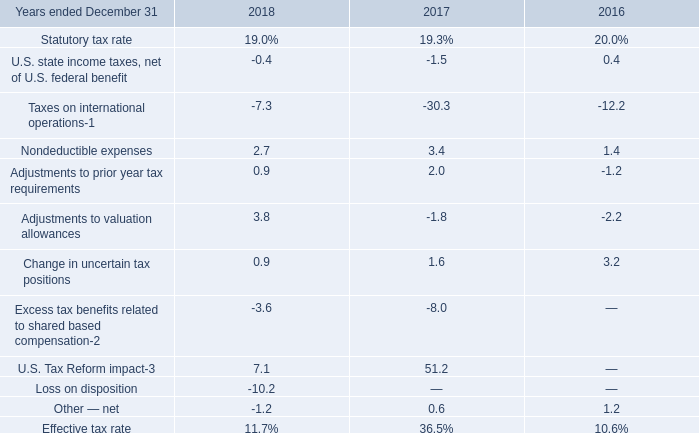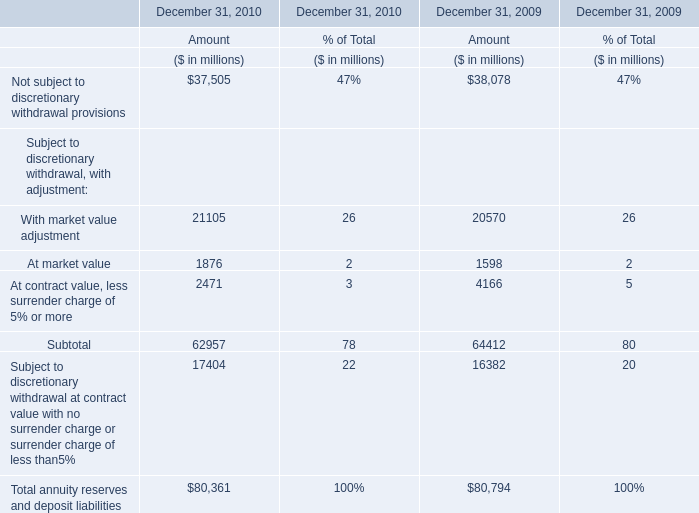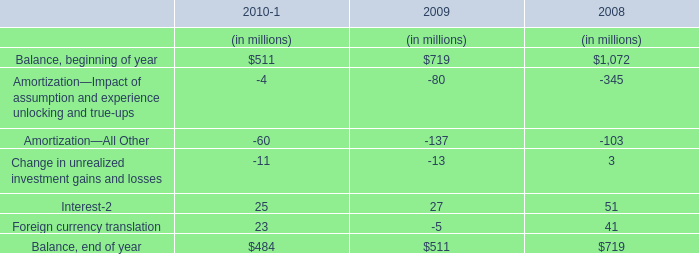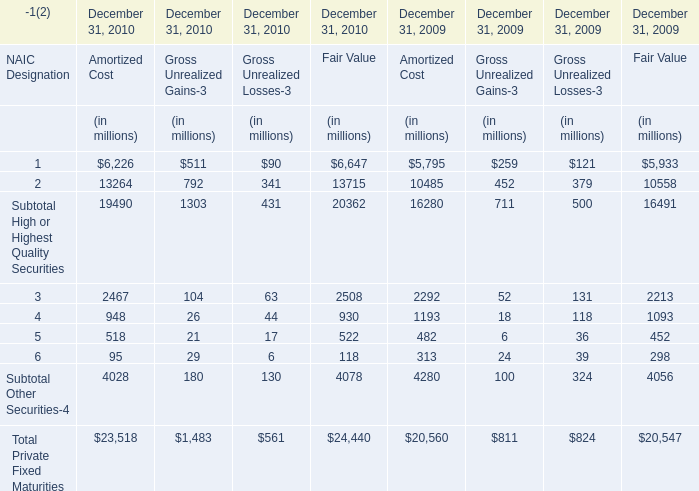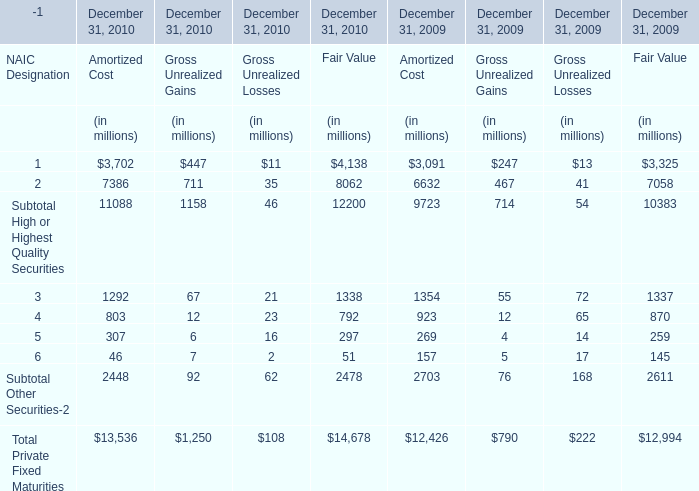What is the ratio of Subtotal Other Securities to the total in 2009 for Fair Value? (in %) 
Computations: (4056 / 20547)
Answer: 0.1974. 